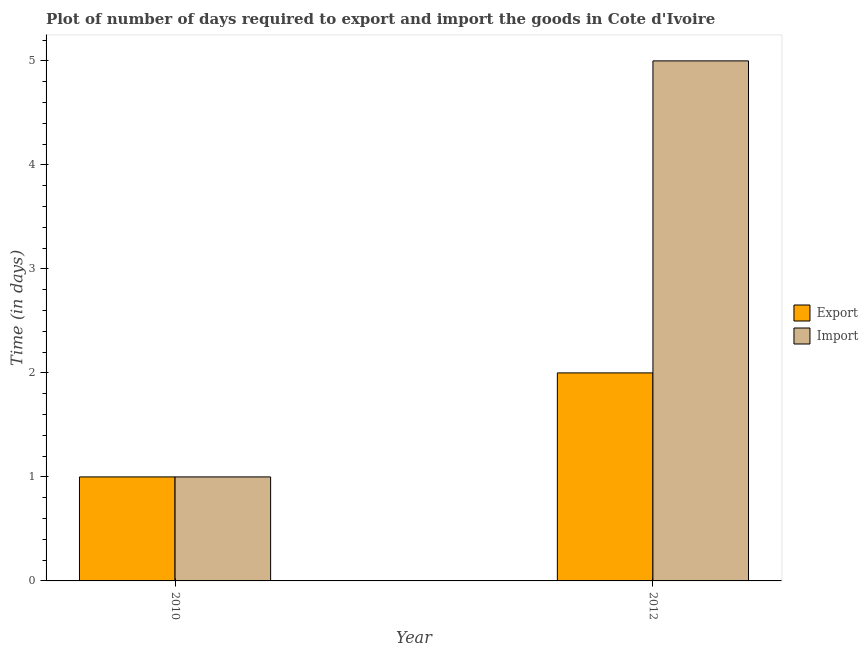How many groups of bars are there?
Provide a succinct answer. 2. Are the number of bars on each tick of the X-axis equal?
Provide a short and direct response. Yes. What is the time required to export in 2010?
Keep it short and to the point. 1. Across all years, what is the maximum time required to export?
Your response must be concise. 2. Across all years, what is the minimum time required to export?
Provide a short and direct response. 1. What is the total time required to export in the graph?
Offer a terse response. 3. What is the difference between the time required to export in 2010 and that in 2012?
Offer a very short reply. -1. What is the difference between the time required to export in 2012 and the time required to import in 2010?
Give a very brief answer. 1. What is the average time required to export per year?
Your response must be concise. 1.5. In the year 2010, what is the difference between the time required to import and time required to export?
Your answer should be very brief. 0. What is the ratio of the time required to import in 2010 to that in 2012?
Offer a terse response. 0.2. What does the 2nd bar from the left in 2012 represents?
Ensure brevity in your answer.  Import. What does the 2nd bar from the right in 2010 represents?
Your answer should be very brief. Export. How many bars are there?
Make the answer very short. 4. Are all the bars in the graph horizontal?
Offer a terse response. No. Are the values on the major ticks of Y-axis written in scientific E-notation?
Your answer should be compact. No. Does the graph contain any zero values?
Your response must be concise. No. What is the title of the graph?
Your answer should be compact. Plot of number of days required to export and import the goods in Cote d'Ivoire. Does "ODA received" appear as one of the legend labels in the graph?
Your response must be concise. No. What is the label or title of the X-axis?
Give a very brief answer. Year. What is the label or title of the Y-axis?
Provide a succinct answer. Time (in days). What is the Time (in days) in Export in 2010?
Offer a very short reply. 1. What is the Time (in days) in Import in 2010?
Give a very brief answer. 1. What is the Time (in days) in Import in 2012?
Your response must be concise. 5. Across all years, what is the maximum Time (in days) of Export?
Keep it short and to the point. 2. Across all years, what is the maximum Time (in days) in Import?
Offer a very short reply. 5. What is the total Time (in days) in Import in the graph?
Provide a short and direct response. 6. What is the difference between the Time (in days) of Import in 2010 and that in 2012?
Offer a very short reply. -4. What is the difference between the Time (in days) in Export in 2010 and the Time (in days) in Import in 2012?
Your answer should be compact. -4. What is the average Time (in days) in Import per year?
Make the answer very short. 3. In the year 2010, what is the difference between the Time (in days) in Export and Time (in days) in Import?
Ensure brevity in your answer.  0. What is the ratio of the Time (in days) of Import in 2010 to that in 2012?
Keep it short and to the point. 0.2. What is the difference between the highest and the second highest Time (in days) in Export?
Your response must be concise. 1. What is the difference between the highest and the second highest Time (in days) in Import?
Provide a succinct answer. 4. What is the difference between the highest and the lowest Time (in days) of Export?
Give a very brief answer. 1. 